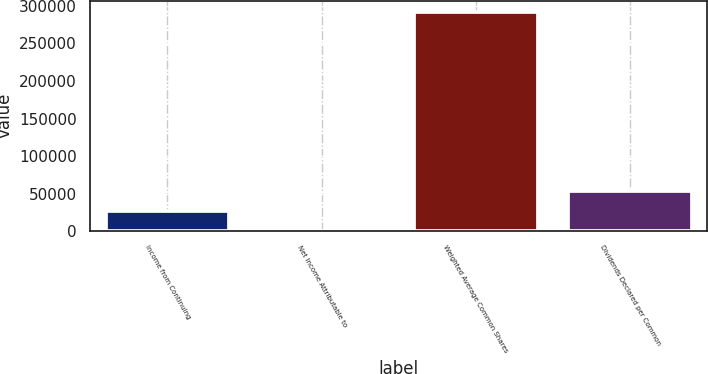Convert chart. <chart><loc_0><loc_0><loc_500><loc_500><bar_chart><fcel>Income from Continuing<fcel>Net Income Attributable to<fcel>Weighted Average Common Shares<fcel>Dividends Declared per Common<nl><fcel>26685.1<fcel>0.69<fcel>292582<fcel>53369.6<nl></chart> 